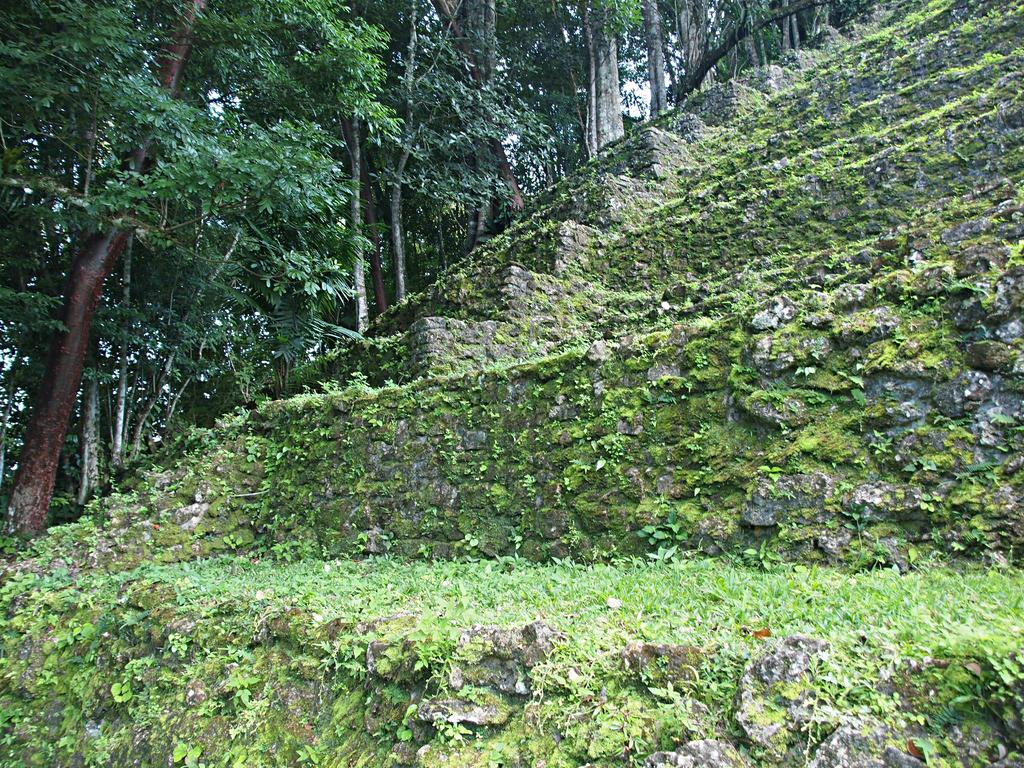What is located in the foreground of the image? There are stairs in the foreground of the image. What is located in the background of the image? There are stairs in the background of the image. What type of list can be seen on the stairs in the image? There is no list present on the stairs in the image. Can you tell me what your uncle is doing on the stairs in the image? There is no person, including an uncle, present in the image. 